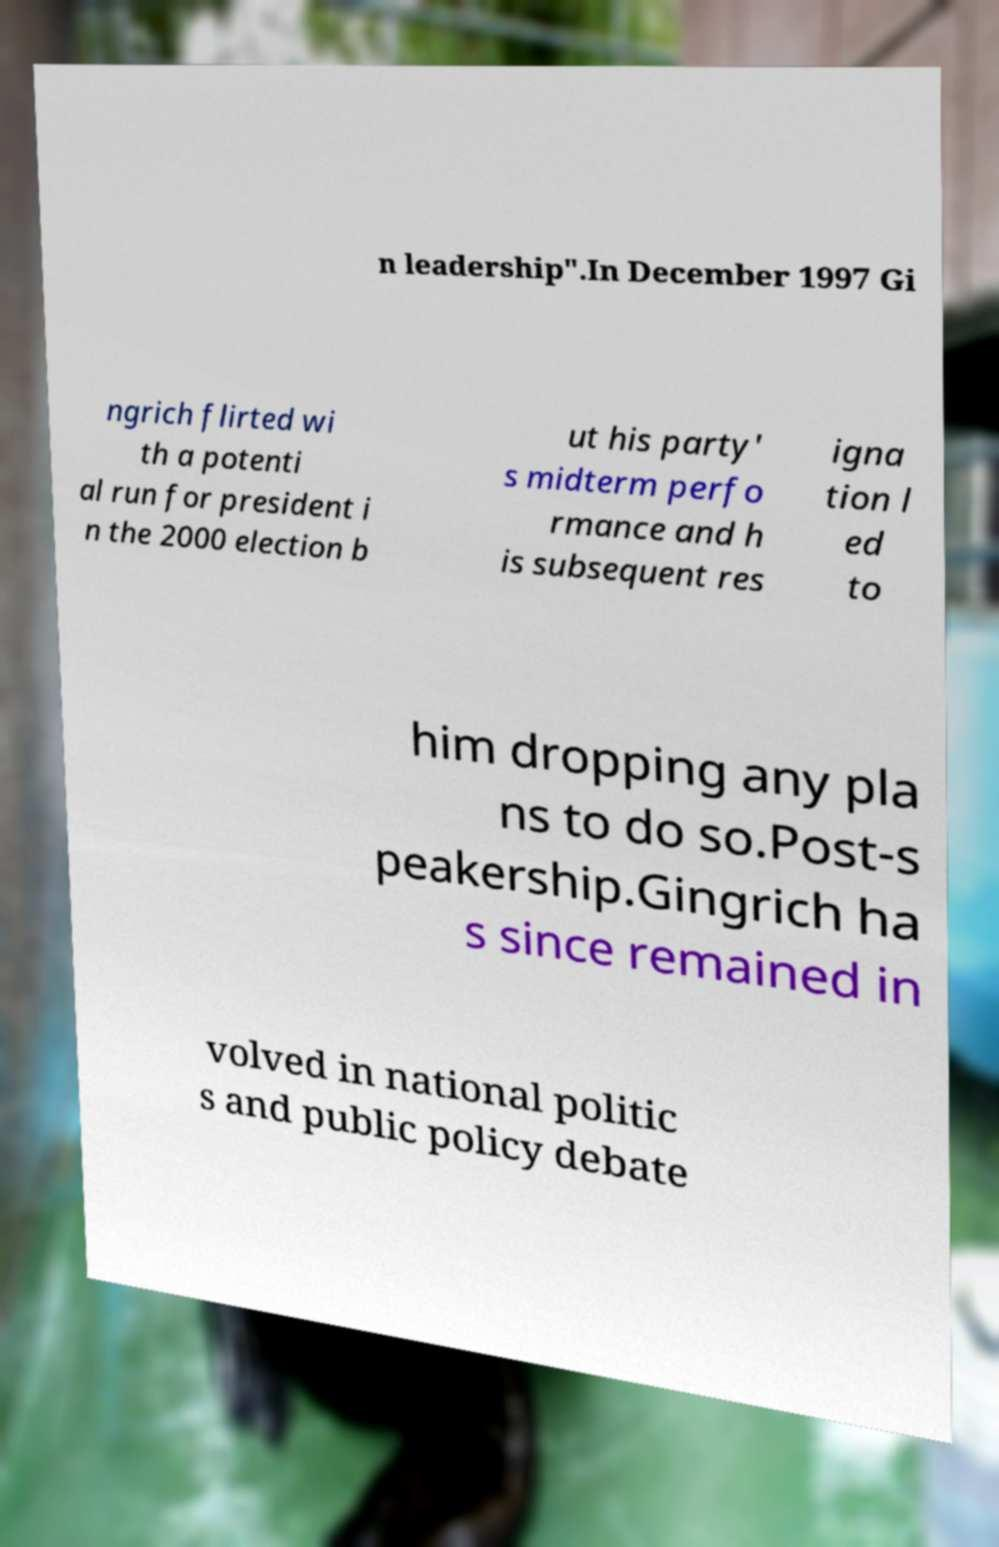I need the written content from this picture converted into text. Can you do that? n leadership".In December 1997 Gi ngrich flirted wi th a potenti al run for president i n the 2000 election b ut his party' s midterm perfo rmance and h is subsequent res igna tion l ed to him dropping any pla ns to do so.Post-s peakership.Gingrich ha s since remained in volved in national politic s and public policy debate 